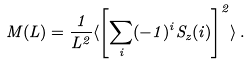Convert formula to latex. <formula><loc_0><loc_0><loc_500><loc_500>M ( L ) = \frac { 1 } { L ^ { 2 } } \langle \left [ \sum _ { i } ( - 1 ) ^ { i } S _ { z } ( i ) \right ] ^ { 2 } \rangle \, .</formula> 